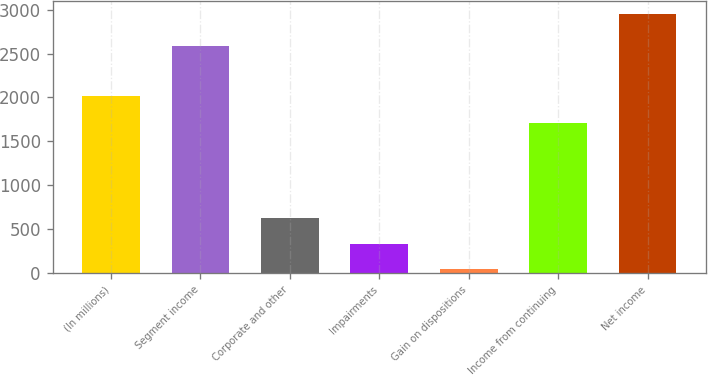<chart> <loc_0><loc_0><loc_500><loc_500><bar_chart><fcel>(In millions)<fcel>Segment income<fcel>Corporate and other<fcel>Impairments<fcel>Gain on dispositions<fcel>Income from continuing<fcel>Net income<nl><fcel>2011<fcel>2591<fcel>625.2<fcel>335.1<fcel>45<fcel>1707<fcel>2946<nl></chart> 